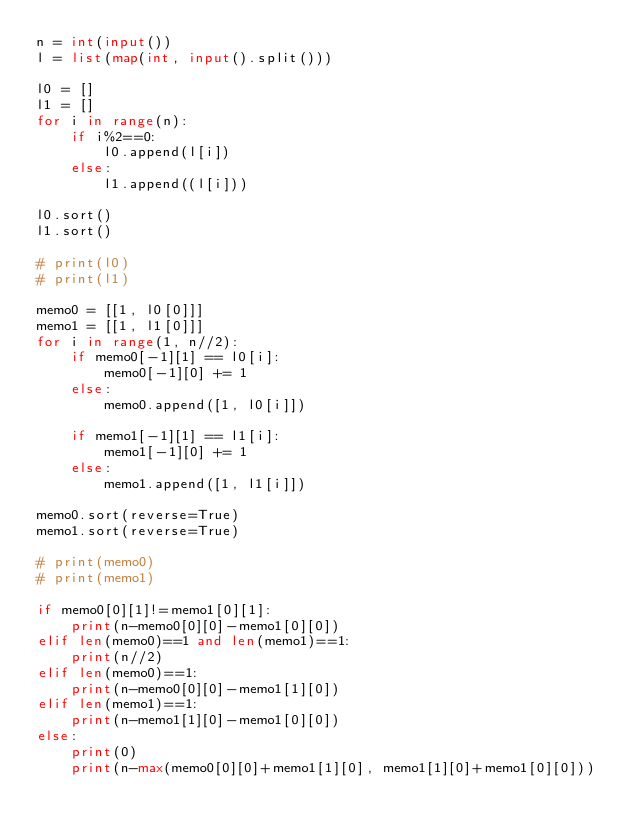Convert code to text. <code><loc_0><loc_0><loc_500><loc_500><_Python_>n = int(input())
l = list(map(int, input().split()))

l0 = []
l1 = []
for i in range(n):
    if i%2==0:
        l0.append(l[i])
    else:
        l1.append((l[i]))

l0.sort()
l1.sort()

# print(l0)
# print(l1)

memo0 = [[1, l0[0]]]
memo1 = [[1, l1[0]]]
for i in range(1, n//2):
    if memo0[-1][1] == l0[i]:
        memo0[-1][0] += 1
    else:
        memo0.append([1, l0[i]])

    if memo1[-1][1] == l1[i]:
        memo1[-1][0] += 1
    else:
        memo1.append([1, l1[i]])

memo0.sort(reverse=True)
memo1.sort(reverse=True)

# print(memo0)
# print(memo1)

if memo0[0][1]!=memo1[0][1]:
    print(n-memo0[0][0]-memo1[0][0])
elif len(memo0)==1 and len(memo1)==1:
    print(n//2)
elif len(memo0)==1:
    print(n-memo0[0][0]-memo1[1][0])
elif len(memo1)==1:
    print(n-memo1[1][0]-memo1[0][0])
else:
    print(0)
    print(n-max(memo0[0][0]+memo1[1][0], memo1[1][0]+memo1[0][0]))</code> 